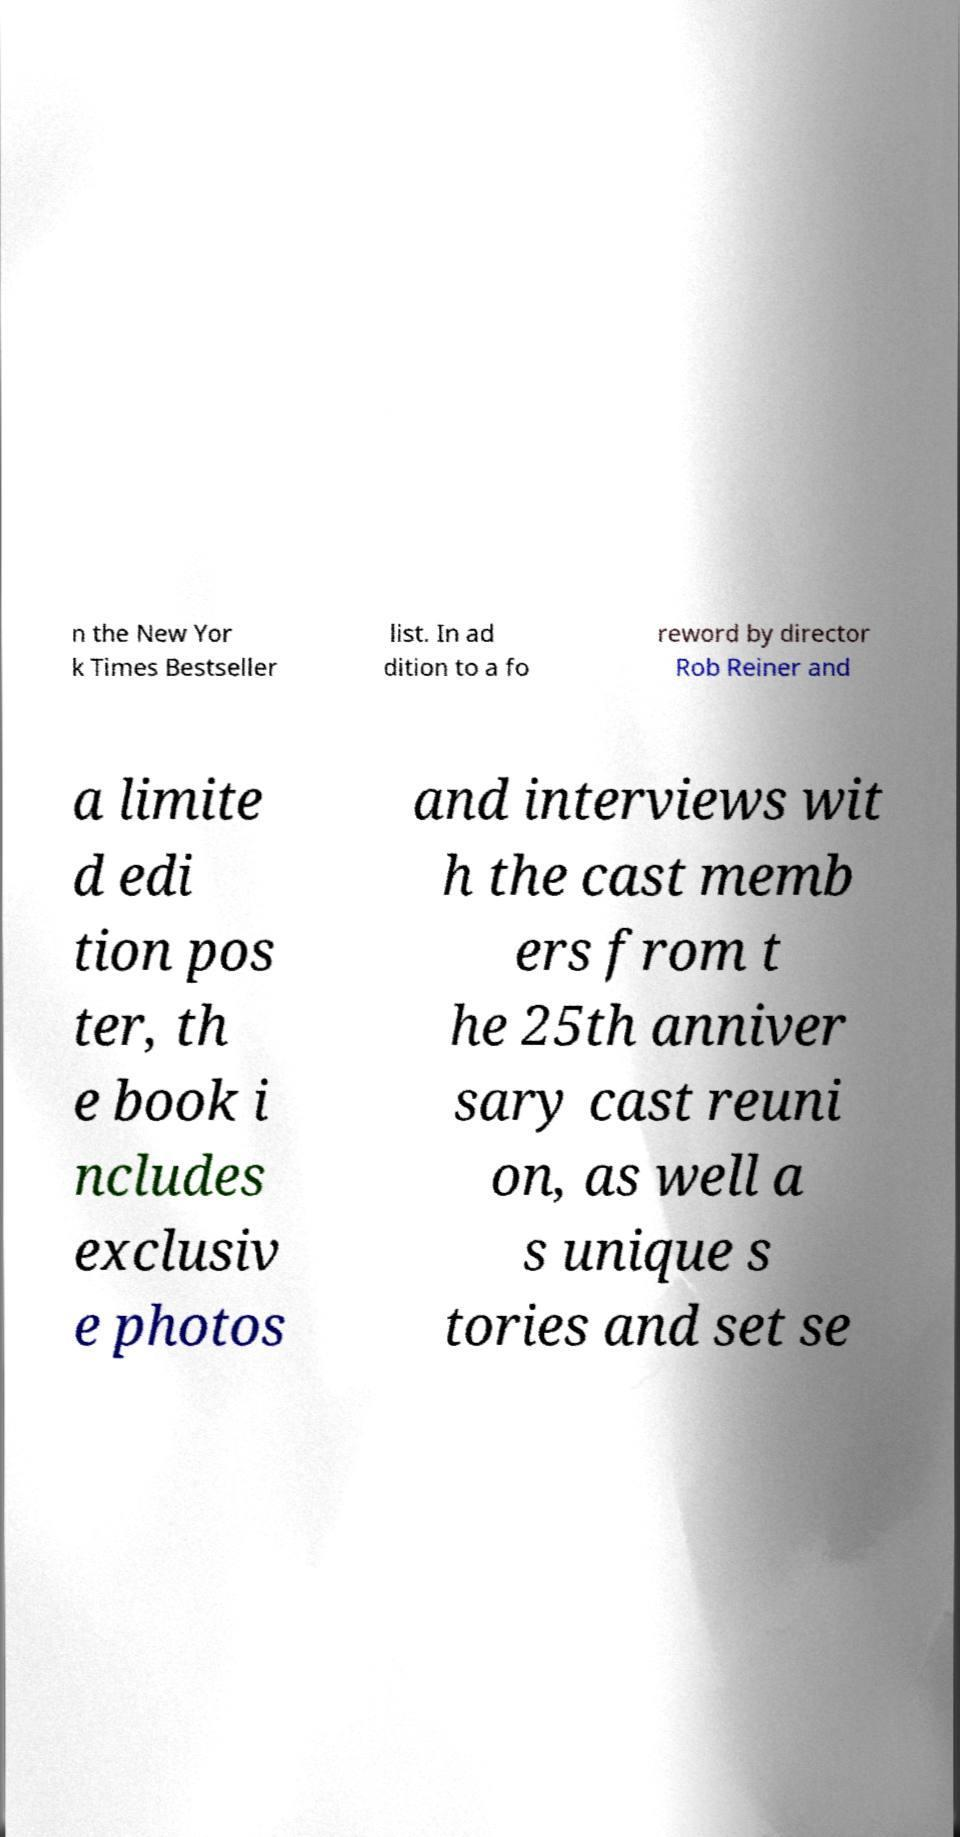Please read and relay the text visible in this image. What does it say? n the New Yor k Times Bestseller list. In ad dition to a fo reword by director Rob Reiner and a limite d edi tion pos ter, th e book i ncludes exclusiv e photos and interviews wit h the cast memb ers from t he 25th anniver sary cast reuni on, as well a s unique s tories and set se 